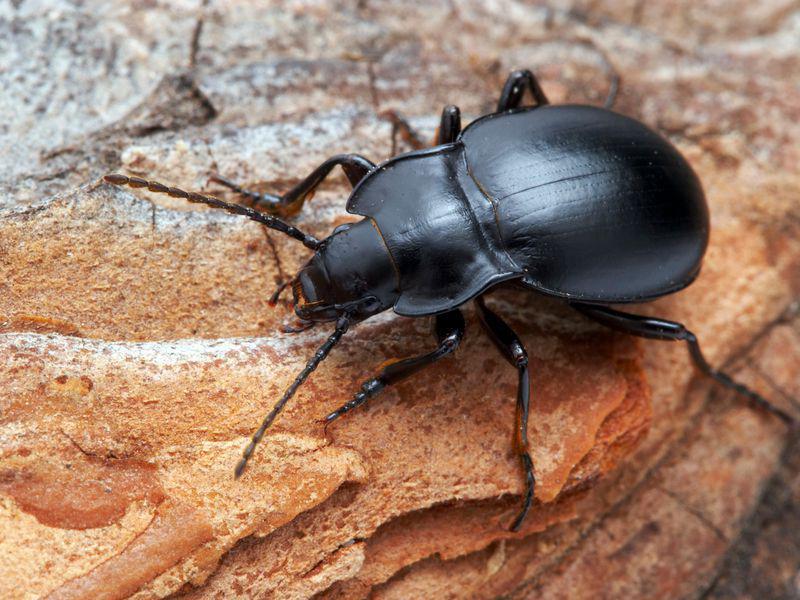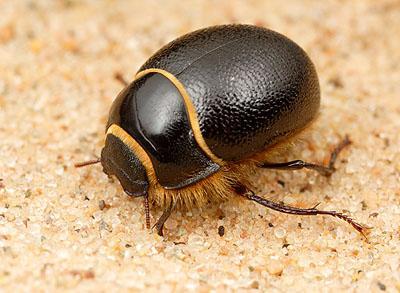The first image is the image on the left, the second image is the image on the right. Analyze the images presented: Is the assertion "There is exactly one insect in the image on the left." valid? Answer yes or no. Yes. 